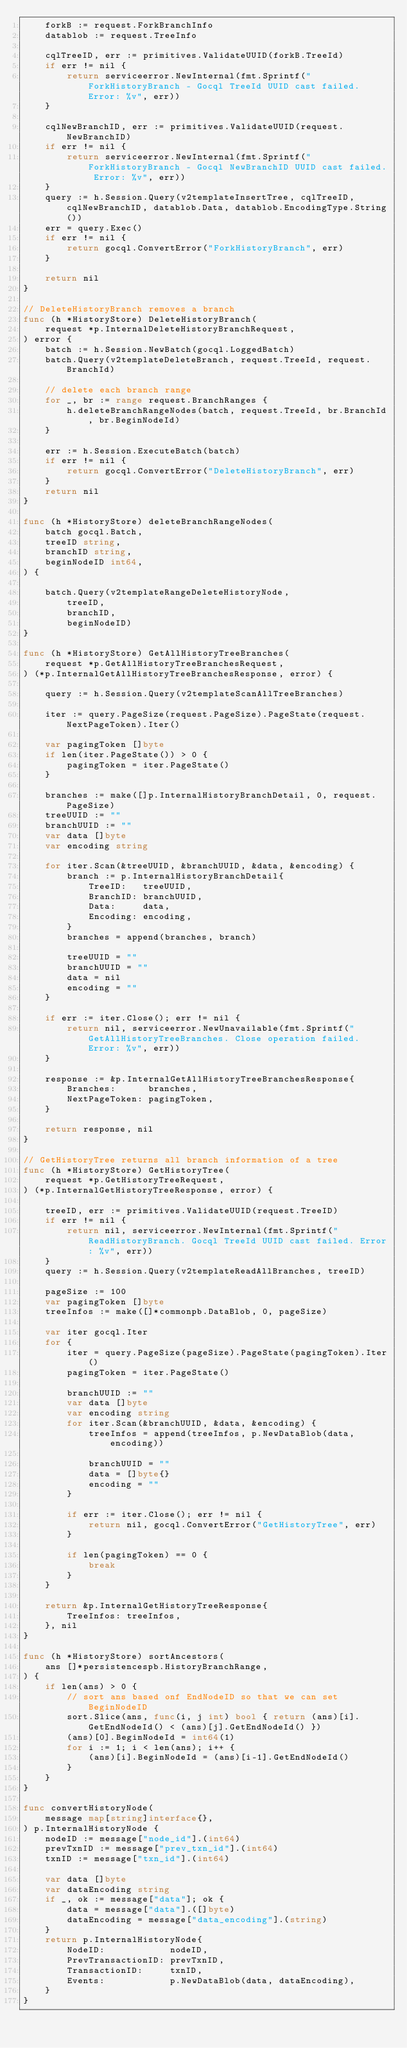<code> <loc_0><loc_0><loc_500><loc_500><_Go_>	forkB := request.ForkBranchInfo
	datablob := request.TreeInfo

	cqlTreeID, err := primitives.ValidateUUID(forkB.TreeId)
	if err != nil {
		return serviceerror.NewInternal(fmt.Sprintf("ForkHistoryBranch - Gocql TreeId UUID cast failed. Error: %v", err))
	}

	cqlNewBranchID, err := primitives.ValidateUUID(request.NewBranchID)
	if err != nil {
		return serviceerror.NewInternal(fmt.Sprintf("ForkHistoryBranch - Gocql NewBranchID UUID cast failed. Error: %v", err))
	}
	query := h.Session.Query(v2templateInsertTree, cqlTreeID, cqlNewBranchID, datablob.Data, datablob.EncodingType.String())
	err = query.Exec()
	if err != nil {
		return gocql.ConvertError("ForkHistoryBranch", err)
	}

	return nil
}

// DeleteHistoryBranch removes a branch
func (h *HistoryStore) DeleteHistoryBranch(
	request *p.InternalDeleteHistoryBranchRequest,
) error {
	batch := h.Session.NewBatch(gocql.LoggedBatch)
	batch.Query(v2templateDeleteBranch, request.TreeId, request.BranchId)

	// delete each branch range
	for _, br := range request.BranchRanges {
		h.deleteBranchRangeNodes(batch, request.TreeId, br.BranchId, br.BeginNodeId)
	}

	err := h.Session.ExecuteBatch(batch)
	if err != nil {
		return gocql.ConvertError("DeleteHistoryBranch", err)
	}
	return nil
}

func (h *HistoryStore) deleteBranchRangeNodes(
	batch gocql.Batch,
	treeID string,
	branchID string,
	beginNodeID int64,
) {

	batch.Query(v2templateRangeDeleteHistoryNode,
		treeID,
		branchID,
		beginNodeID)
}

func (h *HistoryStore) GetAllHistoryTreeBranches(
	request *p.GetAllHistoryTreeBranchesRequest,
) (*p.InternalGetAllHistoryTreeBranchesResponse, error) {

	query := h.Session.Query(v2templateScanAllTreeBranches)

	iter := query.PageSize(request.PageSize).PageState(request.NextPageToken).Iter()

	var pagingToken []byte
	if len(iter.PageState()) > 0 {
		pagingToken = iter.PageState()
	}

	branches := make([]p.InternalHistoryBranchDetail, 0, request.PageSize)
	treeUUID := ""
	branchUUID := ""
	var data []byte
	var encoding string

	for iter.Scan(&treeUUID, &branchUUID, &data, &encoding) {
		branch := p.InternalHistoryBranchDetail{
			TreeID:   treeUUID,
			BranchID: branchUUID,
			Data:     data,
			Encoding: encoding,
		}
		branches = append(branches, branch)

		treeUUID = ""
		branchUUID = ""
		data = nil
		encoding = ""
	}

	if err := iter.Close(); err != nil {
		return nil, serviceerror.NewUnavailable(fmt.Sprintf("GetAllHistoryTreeBranches. Close operation failed. Error: %v", err))
	}

	response := &p.InternalGetAllHistoryTreeBranchesResponse{
		Branches:      branches,
		NextPageToken: pagingToken,
	}

	return response, nil
}

// GetHistoryTree returns all branch information of a tree
func (h *HistoryStore) GetHistoryTree(
	request *p.GetHistoryTreeRequest,
) (*p.InternalGetHistoryTreeResponse, error) {

	treeID, err := primitives.ValidateUUID(request.TreeID)
	if err != nil {
		return nil, serviceerror.NewInternal(fmt.Sprintf("ReadHistoryBranch. Gocql TreeId UUID cast failed. Error: %v", err))
	}
	query := h.Session.Query(v2templateReadAllBranches, treeID)

	pageSize := 100
	var pagingToken []byte
	treeInfos := make([]*commonpb.DataBlob, 0, pageSize)

	var iter gocql.Iter
	for {
		iter = query.PageSize(pageSize).PageState(pagingToken).Iter()
		pagingToken = iter.PageState()

		branchUUID := ""
		var data []byte
		var encoding string
		for iter.Scan(&branchUUID, &data, &encoding) {
			treeInfos = append(treeInfos, p.NewDataBlob(data, encoding))

			branchUUID = ""
			data = []byte{}
			encoding = ""
		}

		if err := iter.Close(); err != nil {
			return nil, gocql.ConvertError("GetHistoryTree", err)
		}

		if len(pagingToken) == 0 {
			break
		}
	}

	return &p.InternalGetHistoryTreeResponse{
		TreeInfos: treeInfos,
	}, nil
}

func (h *HistoryStore) sortAncestors(
	ans []*persistencespb.HistoryBranchRange,
) {
	if len(ans) > 0 {
		// sort ans based onf EndNodeID so that we can set BeginNodeID
		sort.Slice(ans, func(i, j int) bool { return (ans)[i].GetEndNodeId() < (ans)[j].GetEndNodeId() })
		(ans)[0].BeginNodeId = int64(1)
		for i := 1; i < len(ans); i++ {
			(ans)[i].BeginNodeId = (ans)[i-1].GetEndNodeId()
		}
	}
}

func convertHistoryNode(
	message map[string]interface{},
) p.InternalHistoryNode {
	nodeID := message["node_id"].(int64)
	prevTxnID := message["prev_txn_id"].(int64)
	txnID := message["txn_id"].(int64)

	var data []byte
	var dataEncoding string
	if _, ok := message["data"]; ok {
		data = message["data"].([]byte)
		dataEncoding = message["data_encoding"].(string)
	}
	return p.InternalHistoryNode{
		NodeID:            nodeID,
		PrevTransactionID: prevTxnID,
		TransactionID:     txnID,
		Events:            p.NewDataBlob(data, dataEncoding),
	}
}
</code> 